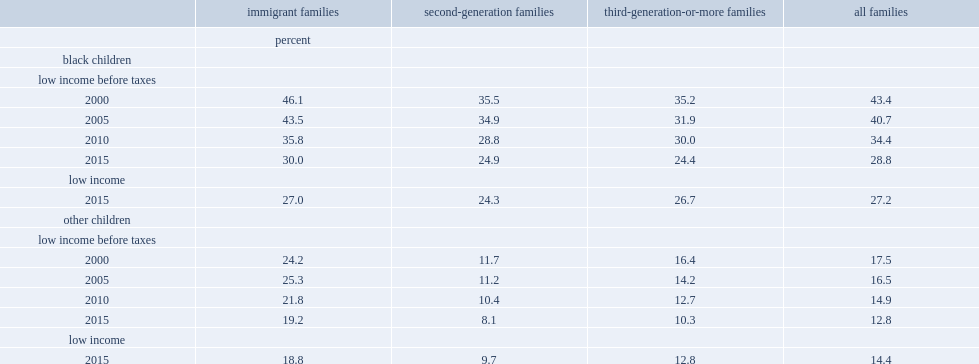In 2015, how many percent of black children and other children, respectively, are affected by low-income status (according to the market basket measure [mbm])? 27.2 14.4. How many percent of black children from second-generation families had low-income status (mbm) in 2015? 24.9. How many percentage points of the before-tax low-income rate for black children born to immigrant families are decreased from 2000 to 2015? 16.1. In 2015, how many times of the low-income rate was higher among black children compared with other children? 1.888889. 